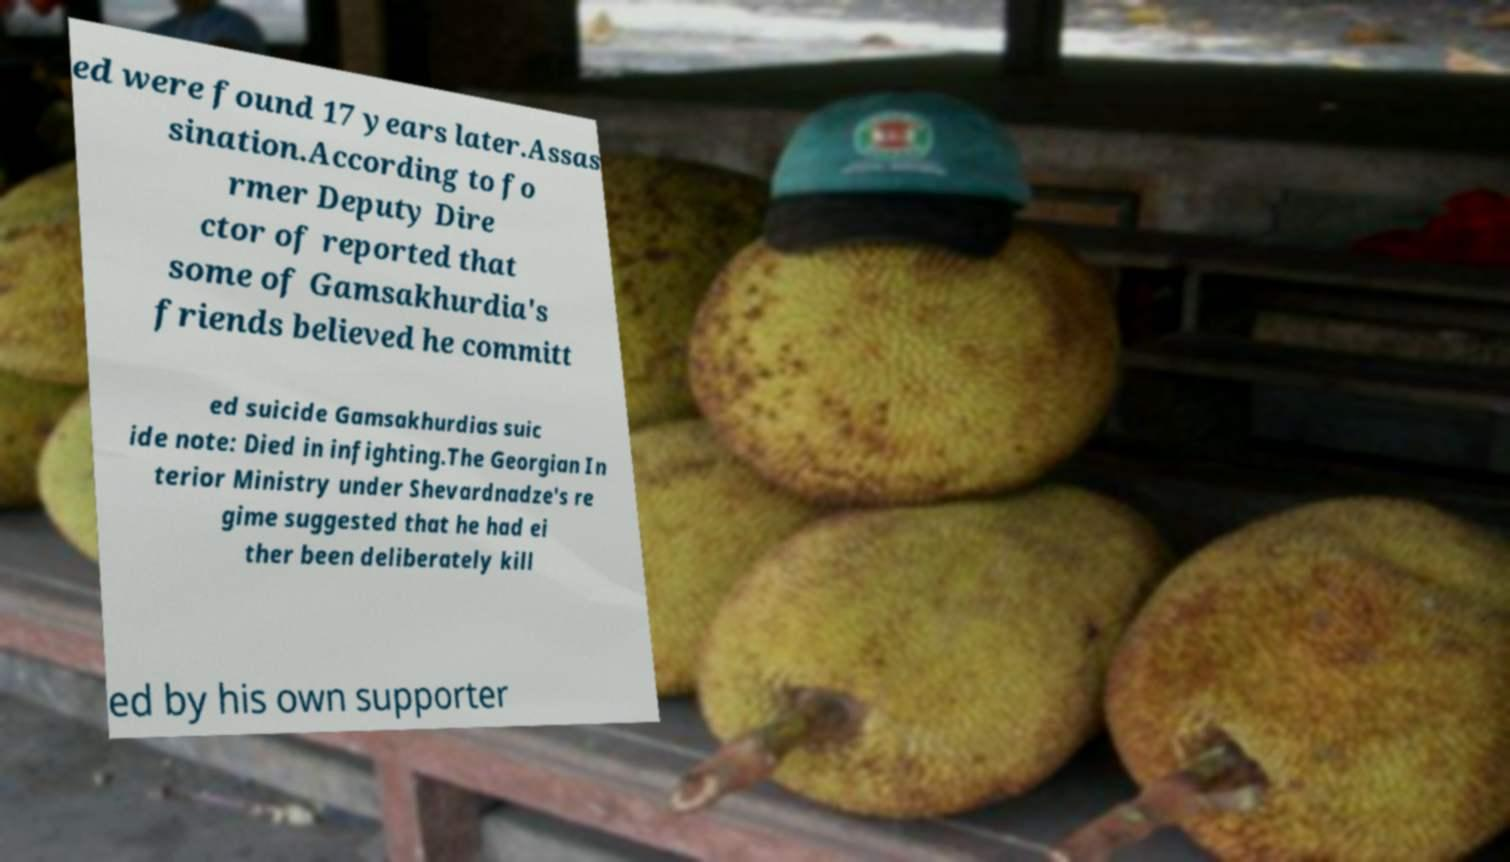What messages or text are displayed in this image? I need them in a readable, typed format. ed were found 17 years later.Assas sination.According to fo rmer Deputy Dire ctor of reported that some of Gamsakhurdia's friends believed he committ ed suicide Gamsakhurdias suic ide note: Died in infighting.The Georgian In terior Ministry under Shevardnadze's re gime suggested that he had ei ther been deliberately kill ed by his own supporter 